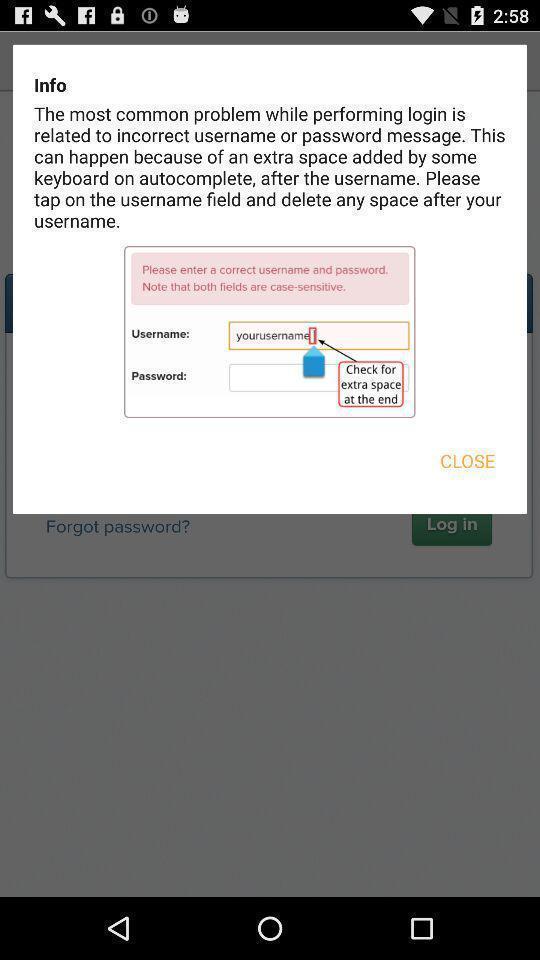Give me a summary of this screen capture. Pop up message. 